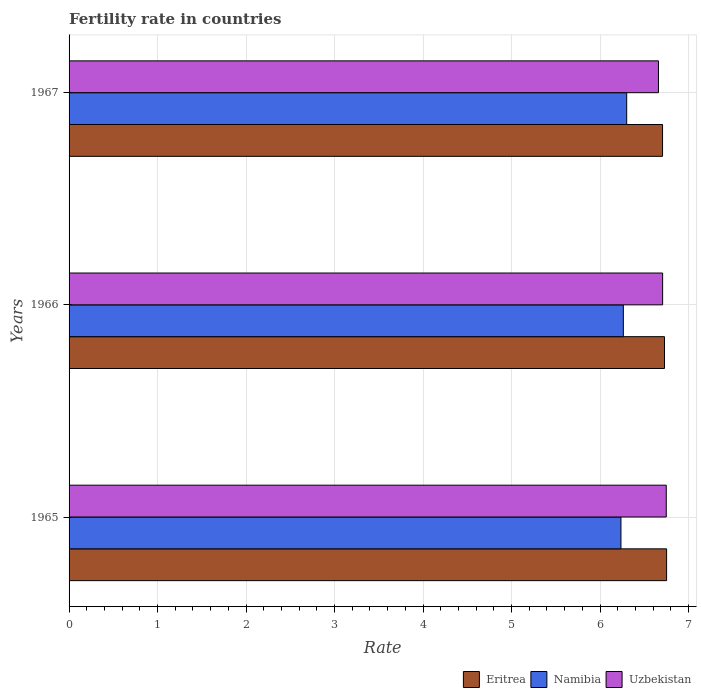Are the number of bars on each tick of the Y-axis equal?
Provide a succinct answer. Yes. How many bars are there on the 2nd tick from the top?
Your response must be concise. 3. What is the label of the 1st group of bars from the top?
Keep it short and to the point. 1967. What is the fertility rate in Uzbekistan in 1967?
Offer a terse response. 6.66. Across all years, what is the maximum fertility rate in Uzbekistan?
Provide a short and direct response. 6.75. Across all years, what is the minimum fertility rate in Uzbekistan?
Provide a short and direct response. 6.66. In which year was the fertility rate in Uzbekistan maximum?
Ensure brevity in your answer.  1965. In which year was the fertility rate in Uzbekistan minimum?
Make the answer very short. 1967. What is the total fertility rate in Eritrea in the graph?
Give a very brief answer. 20.19. What is the difference between the fertility rate in Uzbekistan in 1966 and that in 1967?
Ensure brevity in your answer.  0.05. What is the difference between the fertility rate in Uzbekistan in 1967 and the fertility rate in Eritrea in 1965?
Your response must be concise. -0.09. What is the average fertility rate in Eritrea per year?
Provide a succinct answer. 6.73. In the year 1965, what is the difference between the fertility rate in Eritrea and fertility rate in Namibia?
Provide a succinct answer. 0.52. What is the ratio of the fertility rate in Namibia in 1965 to that in 1967?
Make the answer very short. 0.99. Is the fertility rate in Namibia in 1965 less than that in 1966?
Ensure brevity in your answer.  Yes. What is the difference between the highest and the second highest fertility rate in Namibia?
Offer a terse response. 0.04. What is the difference between the highest and the lowest fertility rate in Uzbekistan?
Ensure brevity in your answer.  0.09. Is the sum of the fertility rate in Uzbekistan in 1966 and 1967 greater than the maximum fertility rate in Eritrea across all years?
Offer a very short reply. Yes. What does the 2nd bar from the top in 1967 represents?
Ensure brevity in your answer.  Namibia. What does the 3rd bar from the bottom in 1966 represents?
Make the answer very short. Uzbekistan. How many bars are there?
Your answer should be compact. 9. Are all the bars in the graph horizontal?
Keep it short and to the point. Yes. How many years are there in the graph?
Give a very brief answer. 3. Does the graph contain any zero values?
Your response must be concise. No. Does the graph contain grids?
Provide a succinct answer. Yes. Where does the legend appear in the graph?
Provide a short and direct response. Bottom right. How are the legend labels stacked?
Make the answer very short. Horizontal. What is the title of the graph?
Provide a short and direct response. Fertility rate in countries. Does "St. Kitts and Nevis" appear as one of the legend labels in the graph?
Offer a very short reply. No. What is the label or title of the X-axis?
Ensure brevity in your answer.  Rate. What is the label or title of the Y-axis?
Offer a very short reply. Years. What is the Rate in Eritrea in 1965?
Ensure brevity in your answer.  6.75. What is the Rate of Namibia in 1965?
Keep it short and to the point. 6.24. What is the Rate in Uzbekistan in 1965?
Offer a terse response. 6.75. What is the Rate in Eritrea in 1966?
Ensure brevity in your answer.  6.73. What is the Rate in Namibia in 1966?
Offer a very short reply. 6.26. What is the Rate in Uzbekistan in 1966?
Offer a terse response. 6.71. What is the Rate of Eritrea in 1967?
Offer a terse response. 6.71. What is the Rate of Namibia in 1967?
Keep it short and to the point. 6.3. What is the Rate of Uzbekistan in 1967?
Make the answer very short. 6.66. Across all years, what is the maximum Rate in Eritrea?
Offer a very short reply. 6.75. Across all years, what is the maximum Rate of Namibia?
Provide a short and direct response. 6.3. Across all years, what is the maximum Rate in Uzbekistan?
Offer a terse response. 6.75. Across all years, what is the minimum Rate of Eritrea?
Make the answer very short. 6.71. Across all years, what is the minimum Rate in Namibia?
Keep it short and to the point. 6.24. Across all years, what is the minimum Rate in Uzbekistan?
Keep it short and to the point. 6.66. What is the total Rate of Eritrea in the graph?
Provide a succinct answer. 20.19. What is the total Rate of Uzbekistan in the graph?
Ensure brevity in your answer.  20.11. What is the difference between the Rate in Eritrea in 1965 and that in 1966?
Offer a very short reply. 0.02. What is the difference between the Rate in Namibia in 1965 and that in 1966?
Provide a short and direct response. -0.03. What is the difference between the Rate in Uzbekistan in 1965 and that in 1966?
Your answer should be compact. 0.04. What is the difference between the Rate in Eritrea in 1965 and that in 1967?
Give a very brief answer. 0.05. What is the difference between the Rate in Namibia in 1965 and that in 1967?
Your answer should be very brief. -0.07. What is the difference between the Rate of Uzbekistan in 1965 and that in 1967?
Ensure brevity in your answer.  0.09. What is the difference between the Rate of Eritrea in 1966 and that in 1967?
Offer a terse response. 0.02. What is the difference between the Rate in Namibia in 1966 and that in 1967?
Offer a very short reply. -0.04. What is the difference between the Rate in Uzbekistan in 1966 and that in 1967?
Keep it short and to the point. 0.05. What is the difference between the Rate of Eritrea in 1965 and the Rate of Namibia in 1966?
Keep it short and to the point. 0.49. What is the difference between the Rate in Eritrea in 1965 and the Rate in Uzbekistan in 1966?
Ensure brevity in your answer.  0.04. What is the difference between the Rate in Namibia in 1965 and the Rate in Uzbekistan in 1966?
Provide a succinct answer. -0.47. What is the difference between the Rate in Eritrea in 1965 and the Rate in Namibia in 1967?
Ensure brevity in your answer.  0.45. What is the difference between the Rate of Eritrea in 1965 and the Rate of Uzbekistan in 1967?
Ensure brevity in your answer.  0.09. What is the difference between the Rate of Namibia in 1965 and the Rate of Uzbekistan in 1967?
Provide a short and direct response. -0.42. What is the difference between the Rate in Eritrea in 1966 and the Rate in Namibia in 1967?
Ensure brevity in your answer.  0.43. What is the difference between the Rate in Eritrea in 1966 and the Rate in Uzbekistan in 1967?
Make the answer very short. 0.07. What is the difference between the Rate of Namibia in 1966 and the Rate of Uzbekistan in 1967?
Offer a terse response. -0.4. What is the average Rate of Eritrea per year?
Make the answer very short. 6.73. What is the average Rate in Namibia per year?
Your response must be concise. 6.27. What is the average Rate in Uzbekistan per year?
Your answer should be very brief. 6.71. In the year 1965, what is the difference between the Rate in Eritrea and Rate in Namibia?
Ensure brevity in your answer.  0.52. In the year 1965, what is the difference between the Rate of Eritrea and Rate of Uzbekistan?
Your answer should be very brief. 0. In the year 1965, what is the difference between the Rate in Namibia and Rate in Uzbekistan?
Give a very brief answer. -0.51. In the year 1966, what is the difference between the Rate in Eritrea and Rate in Namibia?
Your answer should be very brief. 0.47. In the year 1966, what is the difference between the Rate of Eritrea and Rate of Uzbekistan?
Your answer should be very brief. 0.02. In the year 1966, what is the difference between the Rate in Namibia and Rate in Uzbekistan?
Make the answer very short. -0.44. In the year 1967, what is the difference between the Rate of Eritrea and Rate of Namibia?
Provide a short and direct response. 0.41. In the year 1967, what is the difference between the Rate of Eritrea and Rate of Uzbekistan?
Make the answer very short. 0.05. In the year 1967, what is the difference between the Rate in Namibia and Rate in Uzbekistan?
Give a very brief answer. -0.36. What is the ratio of the Rate of Eritrea in 1965 to that in 1966?
Your response must be concise. 1. What is the ratio of the Rate in Uzbekistan in 1965 to that in 1966?
Your answer should be compact. 1.01. What is the ratio of the Rate of Uzbekistan in 1965 to that in 1967?
Ensure brevity in your answer.  1.01. What is the ratio of the Rate in Eritrea in 1966 to that in 1967?
Your answer should be very brief. 1. What is the ratio of the Rate in Namibia in 1966 to that in 1967?
Offer a terse response. 0.99. What is the ratio of the Rate in Uzbekistan in 1966 to that in 1967?
Give a very brief answer. 1.01. What is the difference between the highest and the second highest Rate of Eritrea?
Provide a succinct answer. 0.02. What is the difference between the highest and the second highest Rate of Namibia?
Your response must be concise. 0.04. What is the difference between the highest and the second highest Rate of Uzbekistan?
Offer a very short reply. 0.04. What is the difference between the highest and the lowest Rate in Eritrea?
Provide a short and direct response. 0.05. What is the difference between the highest and the lowest Rate of Namibia?
Offer a terse response. 0.07. What is the difference between the highest and the lowest Rate of Uzbekistan?
Offer a terse response. 0.09. 